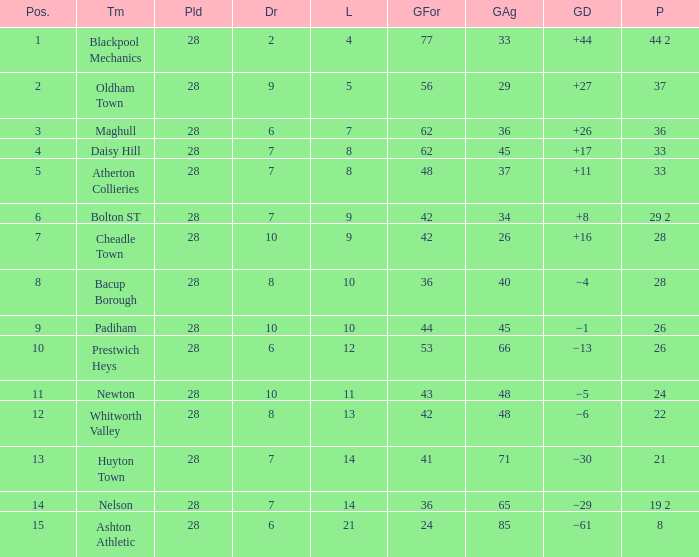For entries with fewer than 28 played, with 45 goals against and points 1 of 33, what is the average drawn? None. 